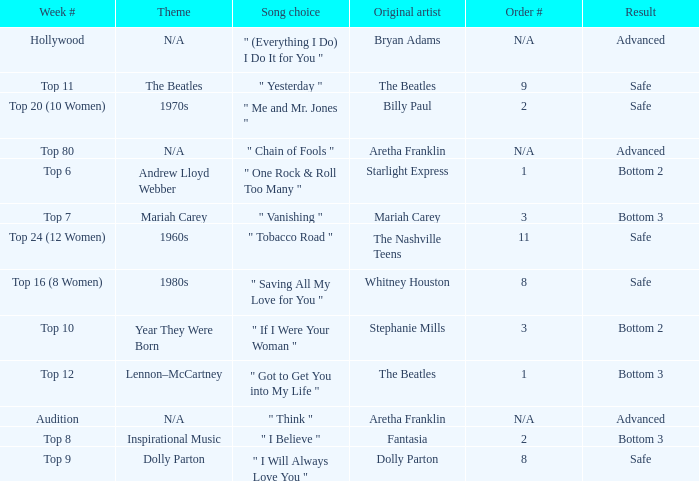Name the order number for the beatles and result is safe 9.0. 